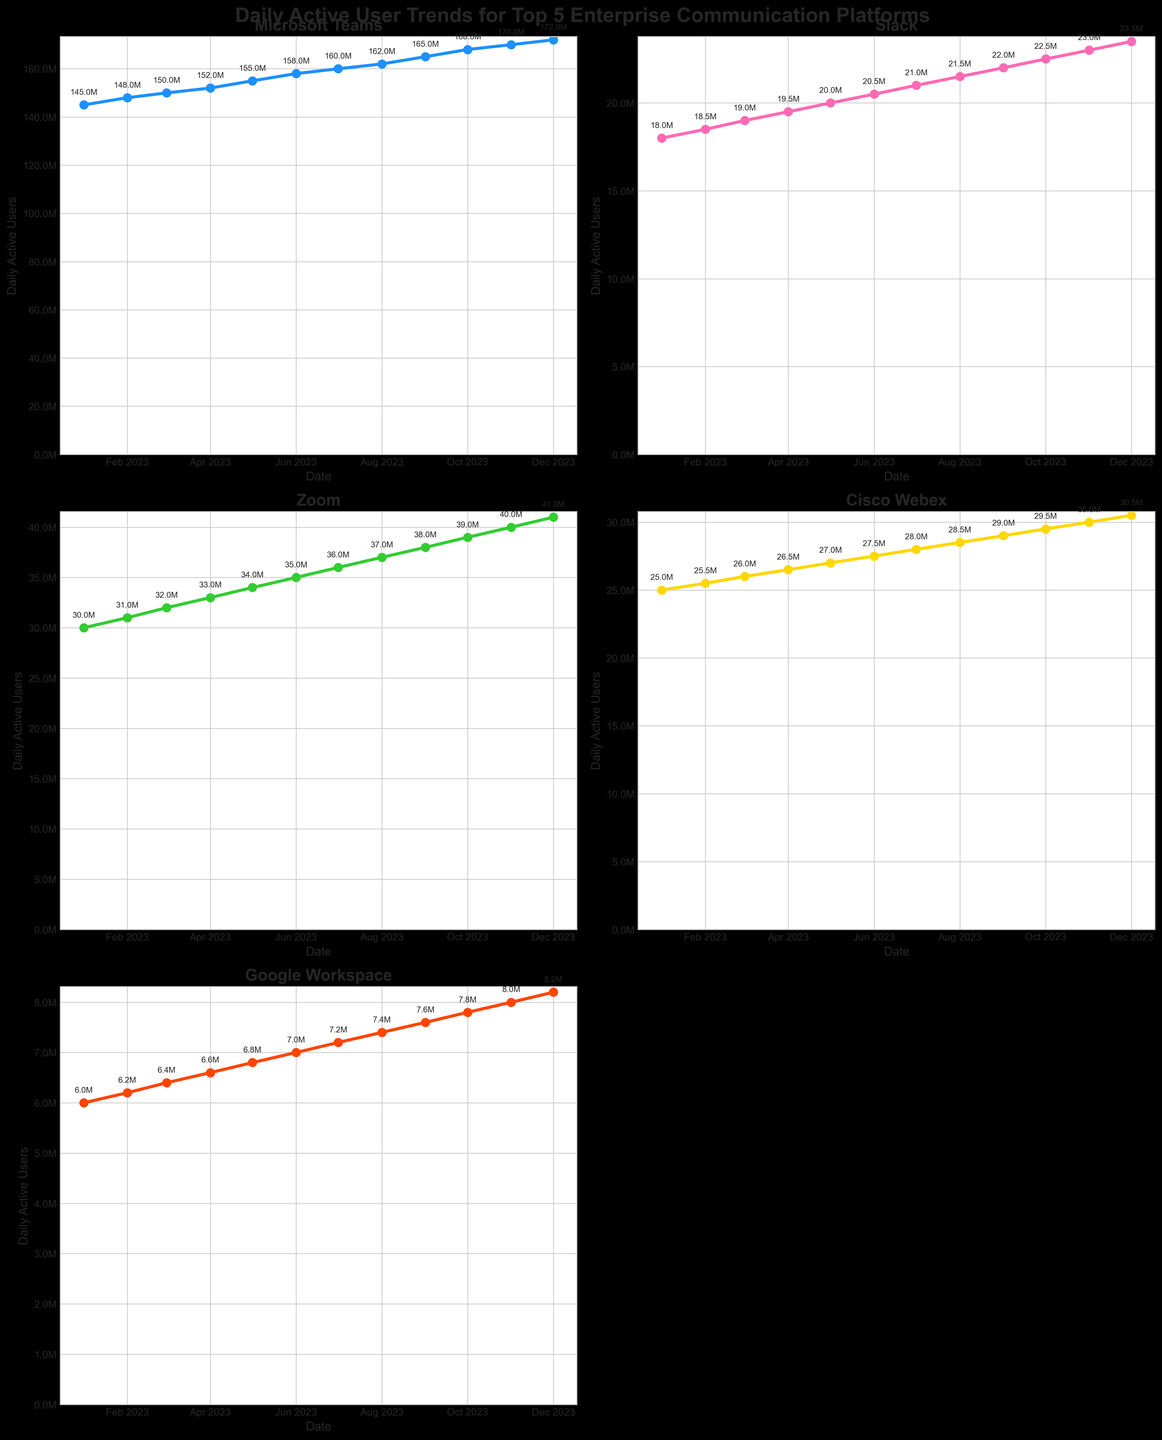What is the title of the figure? The title of the figure is displayed prominently at the top of the plot and reads 'Daily Active User Trends for Top 5 Enterprise Communication Platforms'.
Answer: Daily Active User Trends for Top 5 Enterprise Communication Platforms Which platform showed the highest daily active users in October 2023? By examining the plotted values for October 2023, Microsoft Teams has the highest number of daily active users with 168 million.
Answer: Microsoft Teams How many platforms have daily active users exceeding 30 million by December 2023? From the plotted values in December 2023, Microsoft Teams (172 million), Zoom (41 million), and Cisco Webex (30.5 million) each have over 30 million daily active users.
Answer: 3 Which platform had the smallest increase in daily active users from January to December 2023? To determine the smallest increase, we compare the difference in daily active users between January and December 2023. Google Workspace increased from 6 million to 8.2 million, resulting in an increase of 2.2 million, which is the smallest among the platforms.
Answer: Google Workspace Between which months did Slack show the most significant increase in daily active users? By comparing the monthly increases, Slack rose the most significantly from October to November 2023, increasing from 22 million to 23 million, an increase of 1 million users.
Answer: October to November 2023 Which platform shows a continuous upward trend without any dips throughout the year? Analyzing each subplot line visually, all platforms show a continuous upward trend without any dips throughout the year.
Answer: All platforms What is the average number of daily active users for Zoom in 2023? Summing up Zoom's monthly users: \(30M + 31M + 32M + 33M + 34M + 35M + 36M + 37M + 38M + 39M + 40M + 41M = 426\), then dividing by 12: \(426M / 12 = 35.5M\).
Answer: 35.5 million How much more daily active users did Microsoft Teams have compared to Zoom in December 2023? Microsoft Teams had 172 million daily active users, while Zoom had 41 million. The difference is \(172M - 41M = 131M\).
Answer: 131 million When did Google Workspace reach 7 million daily active users? Google Workspace reached 7 million daily active users in June 2023, as indicated by the plotted values.
Answer: June 2023 